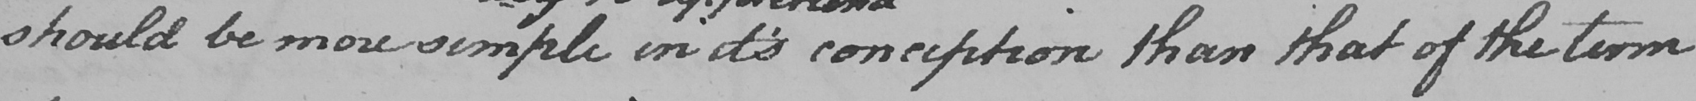What text is written in this handwritten line? should be more simple in it ' s conception than that of the term 